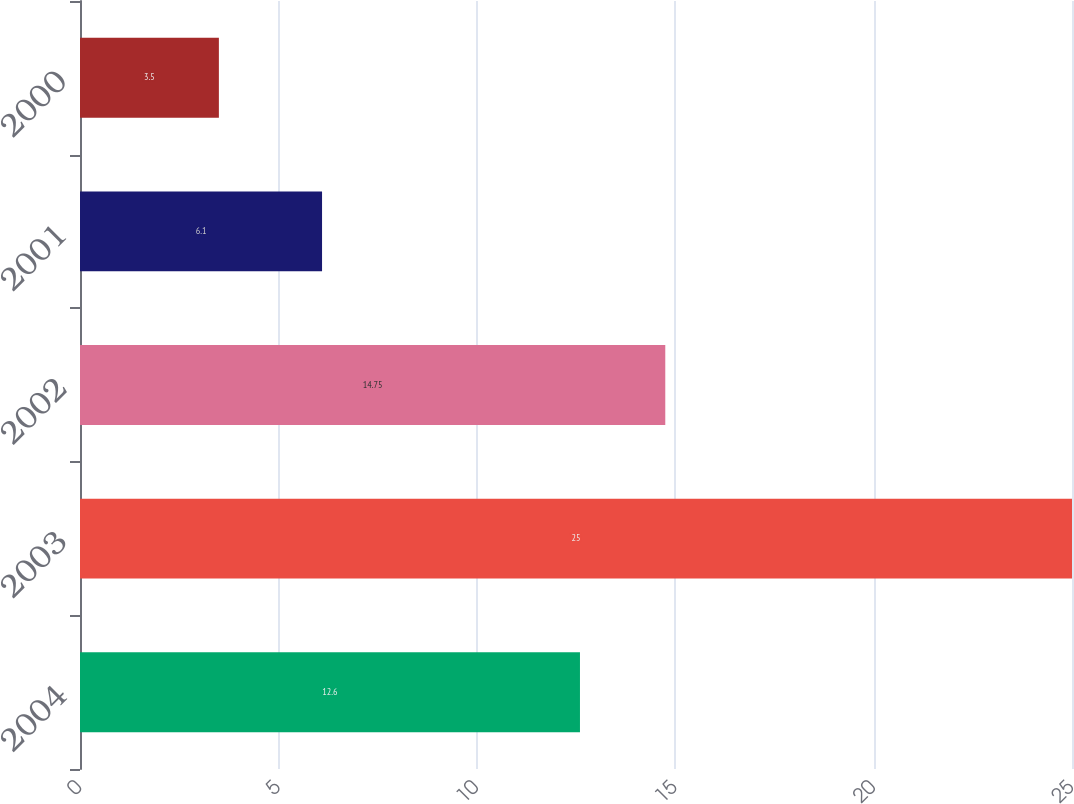<chart> <loc_0><loc_0><loc_500><loc_500><bar_chart><fcel>2004<fcel>2003<fcel>2002<fcel>2001<fcel>2000<nl><fcel>12.6<fcel>25<fcel>14.75<fcel>6.1<fcel>3.5<nl></chart> 